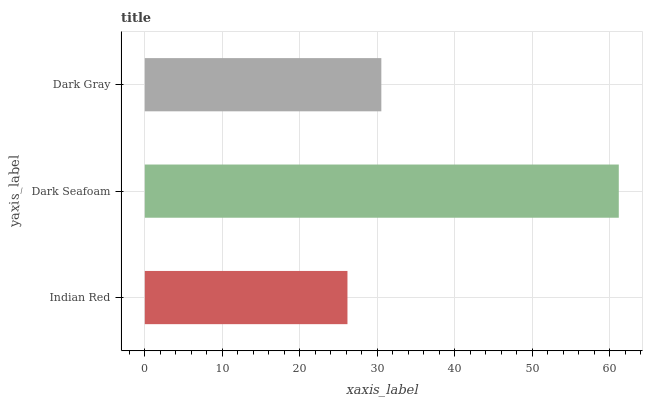Is Indian Red the minimum?
Answer yes or no. Yes. Is Dark Seafoam the maximum?
Answer yes or no. Yes. Is Dark Gray the minimum?
Answer yes or no. No. Is Dark Gray the maximum?
Answer yes or no. No. Is Dark Seafoam greater than Dark Gray?
Answer yes or no. Yes. Is Dark Gray less than Dark Seafoam?
Answer yes or no. Yes. Is Dark Gray greater than Dark Seafoam?
Answer yes or no. No. Is Dark Seafoam less than Dark Gray?
Answer yes or no. No. Is Dark Gray the high median?
Answer yes or no. Yes. Is Dark Gray the low median?
Answer yes or no. Yes. Is Dark Seafoam the high median?
Answer yes or no. No. Is Dark Seafoam the low median?
Answer yes or no. No. 